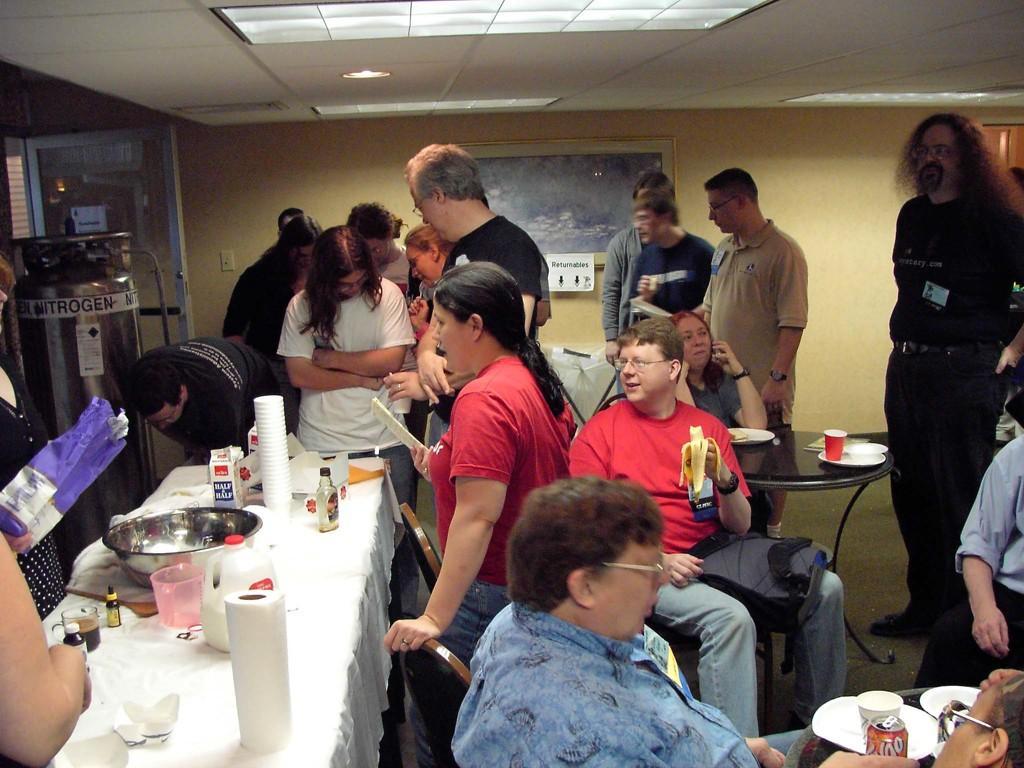Can you describe this image briefly? People are present in a room. some of them are seated. There are black tables on which there plates, can, glasses. A person is eating a banana. There is a table at the left on which there are glasses, jug, tissue roll and other objects. There is a photo frame on the wall. 